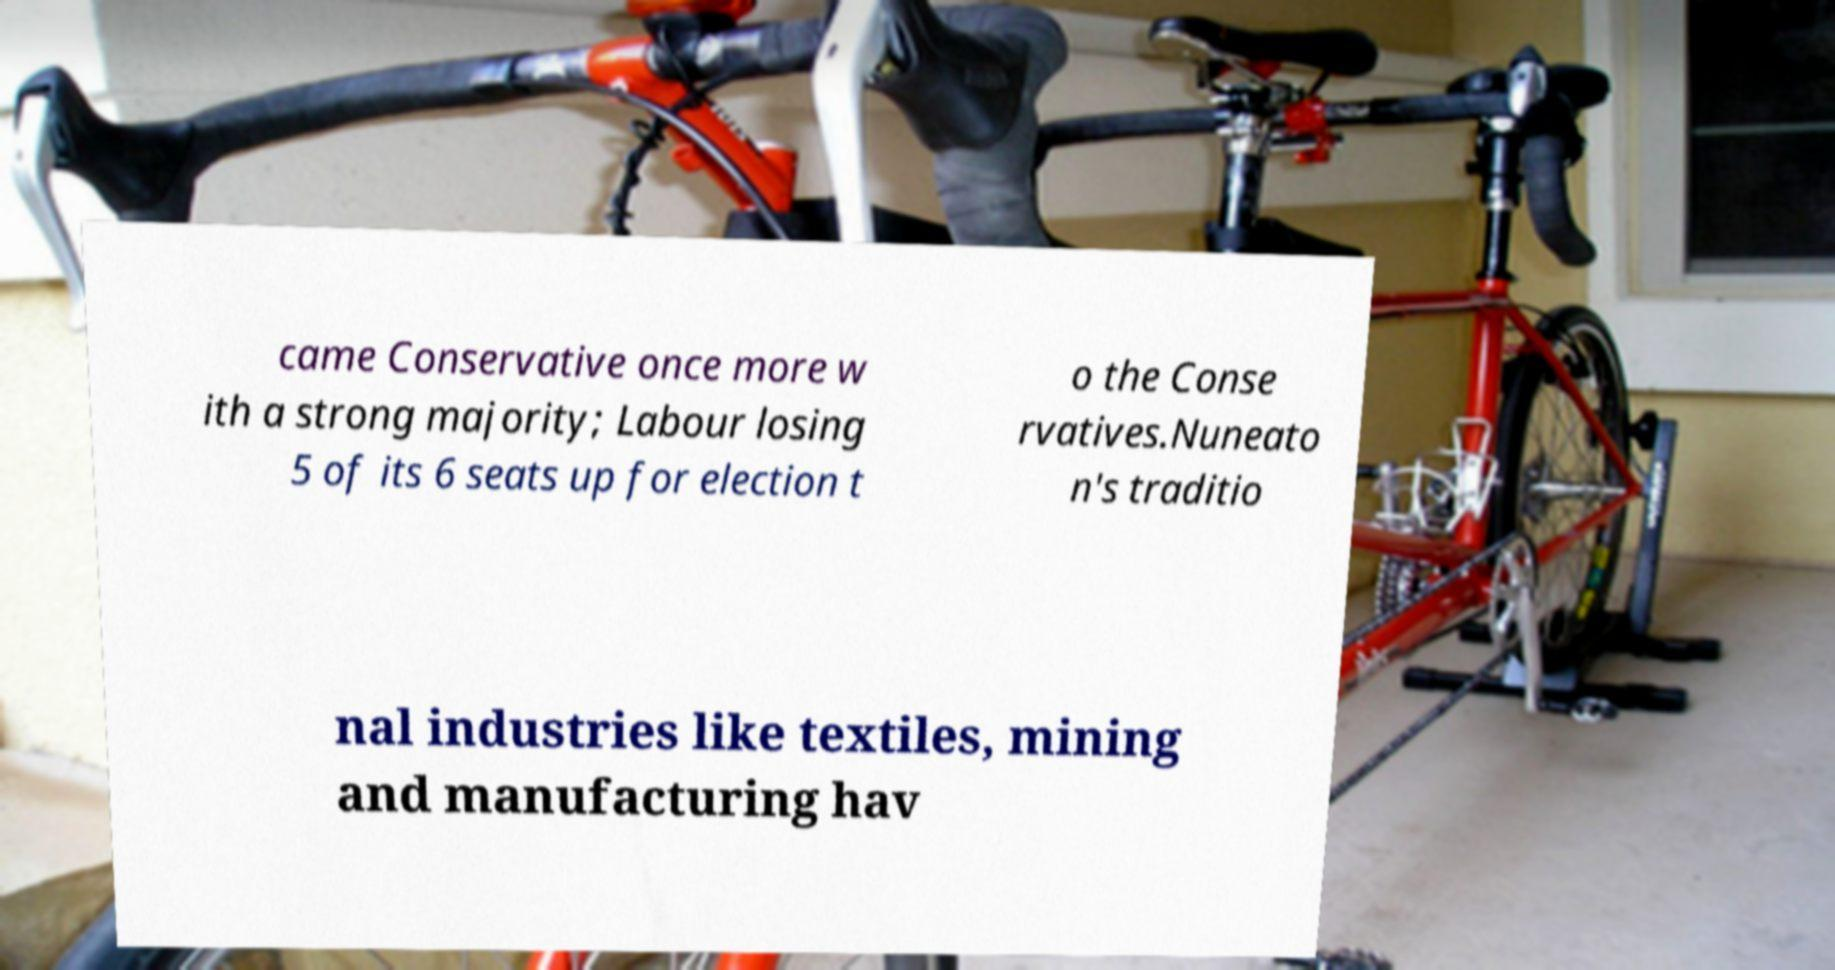For documentation purposes, I need the text within this image transcribed. Could you provide that? came Conservative once more w ith a strong majority; Labour losing 5 of its 6 seats up for election t o the Conse rvatives.Nuneato n's traditio nal industries like textiles, mining and manufacturing hav 